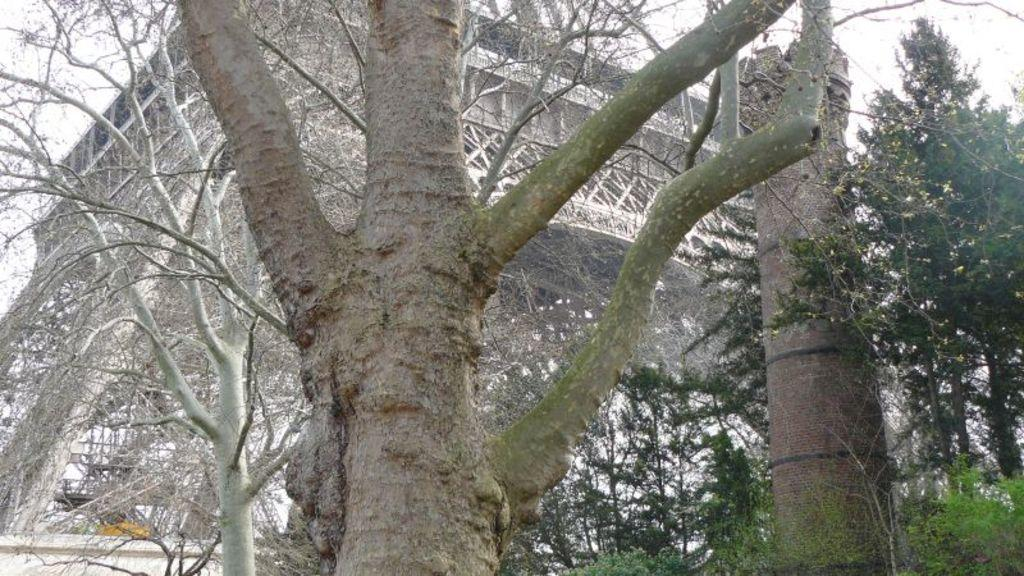What type of vegetation can be seen in the image? There are trees in the image. What structure is present in the image? There is a building in the image. What is visible at the top of the image? The sky is visible at the top of the image. How many pigs are attacking the building in the image? There are no pigs or any indication of an attack present in the image. What type of art is displayed on the building in the image? There is no art visible on the building in the image. 